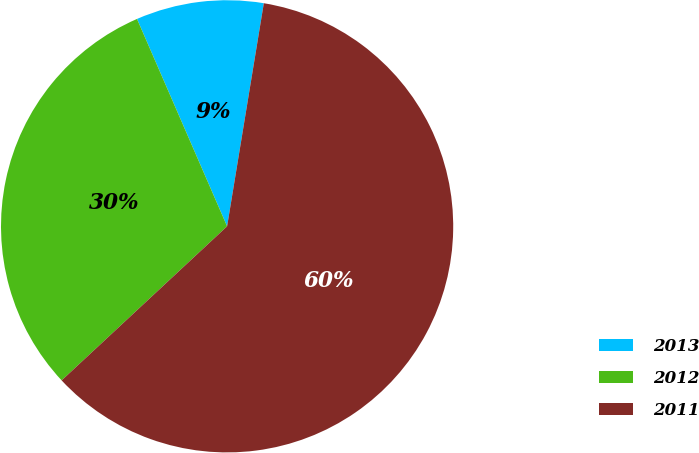Convert chart. <chart><loc_0><loc_0><loc_500><loc_500><pie_chart><fcel>2013<fcel>2012<fcel>2011<nl><fcel>9.12%<fcel>30.41%<fcel>60.47%<nl></chart> 